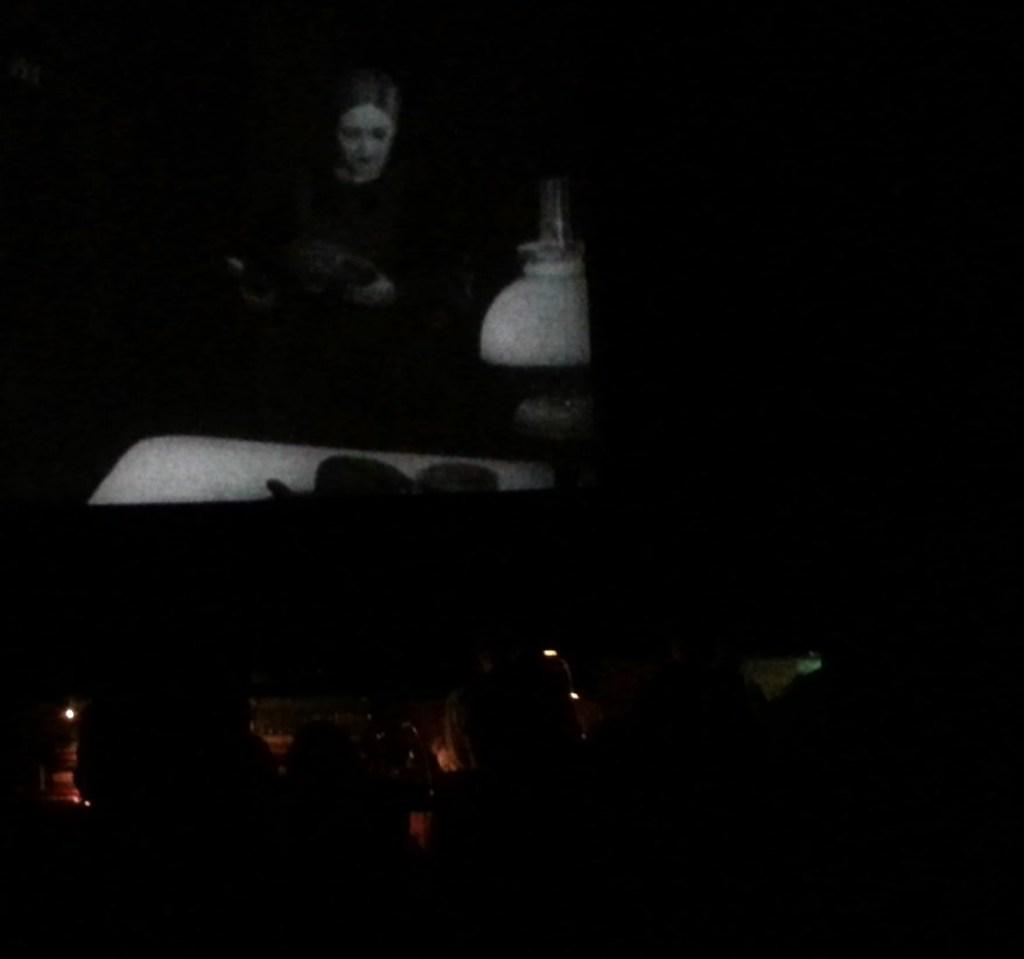What is the main activity of the persons in the image? The persons in the image are sitting in a cinema hall. Where are the persons sitting in relation to the screen? The persons are sitting in the front. What is the primary feature in the center of the cinema hall? There is a screen in the center of the cinema hall. What is being displayed on the screen? A cinema is playing on the screen. How many trucks are parked outside the cinema in the image? There is no information about trucks or any outdoor setting in the image; it only shows the interior of the cinema hall. What type of feather can be seen on the persons sitting in the cinema? There are no feathers visible on the persons sitting in the cinema in the image. 